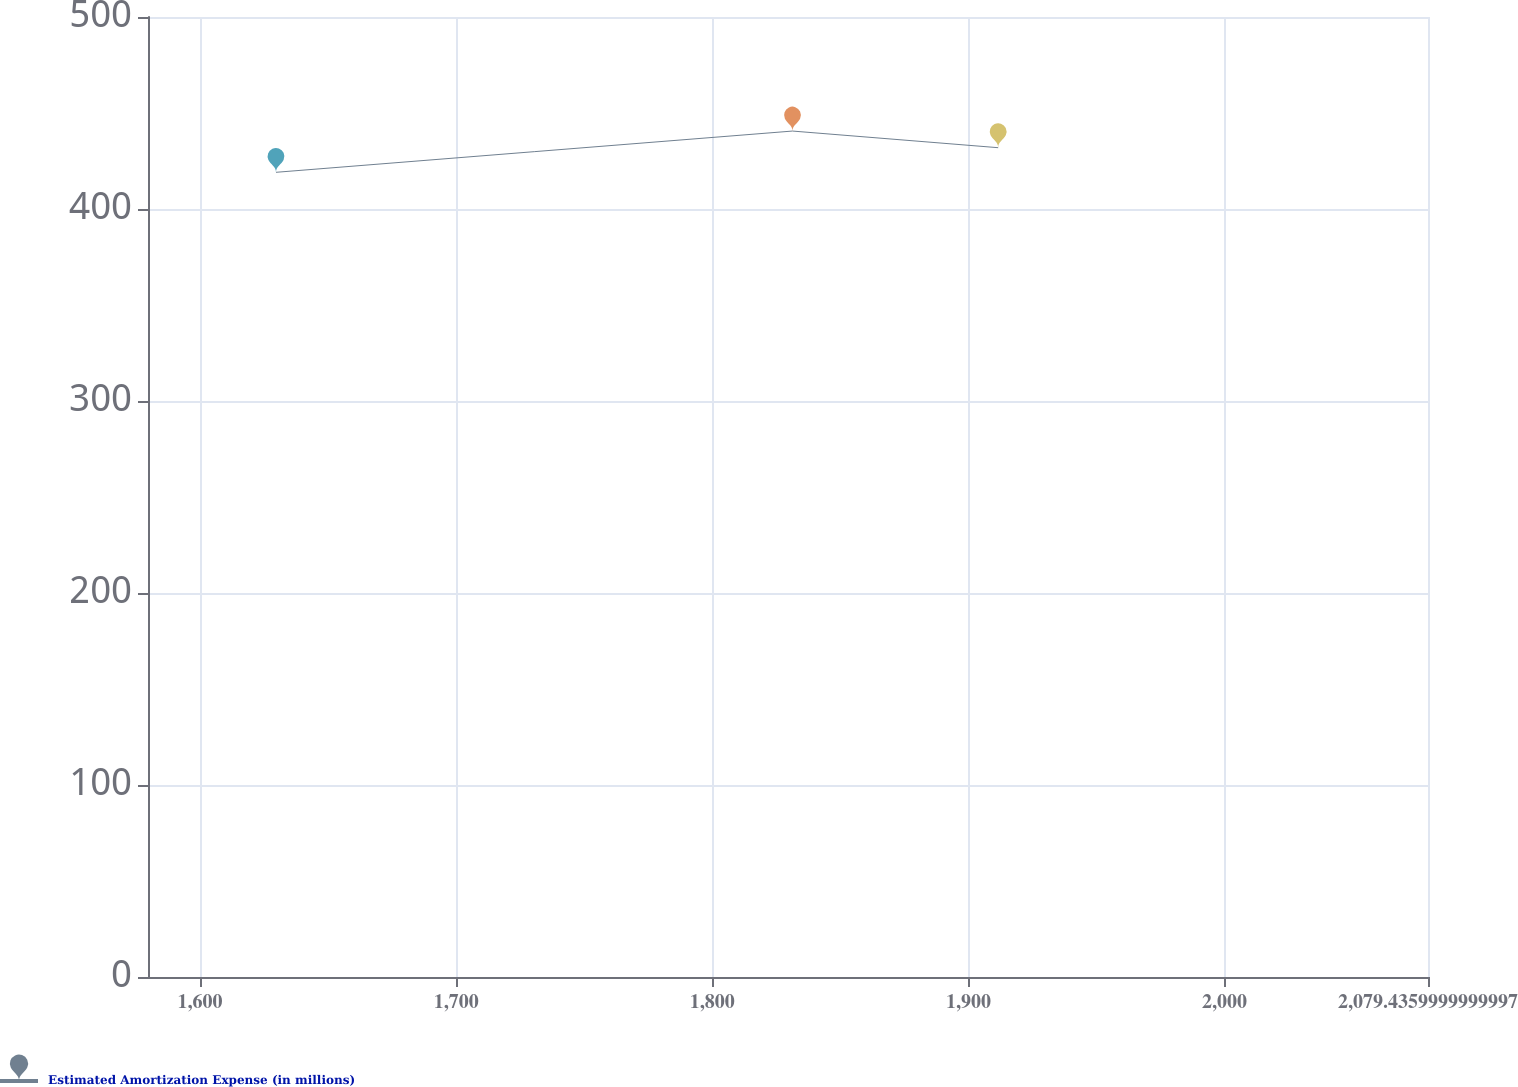<chart> <loc_0><loc_0><loc_500><loc_500><line_chart><ecel><fcel>Estimated Amortization Expense (in millions)<nl><fcel>1629.67<fcel>419.11<nl><fcel>1831.32<fcel>440.6<nl><fcel>1911.62<fcel>431.93<nl><fcel>2080.71<fcel>423.52<nl><fcel>2129.41<fcel>448.8<nl></chart> 